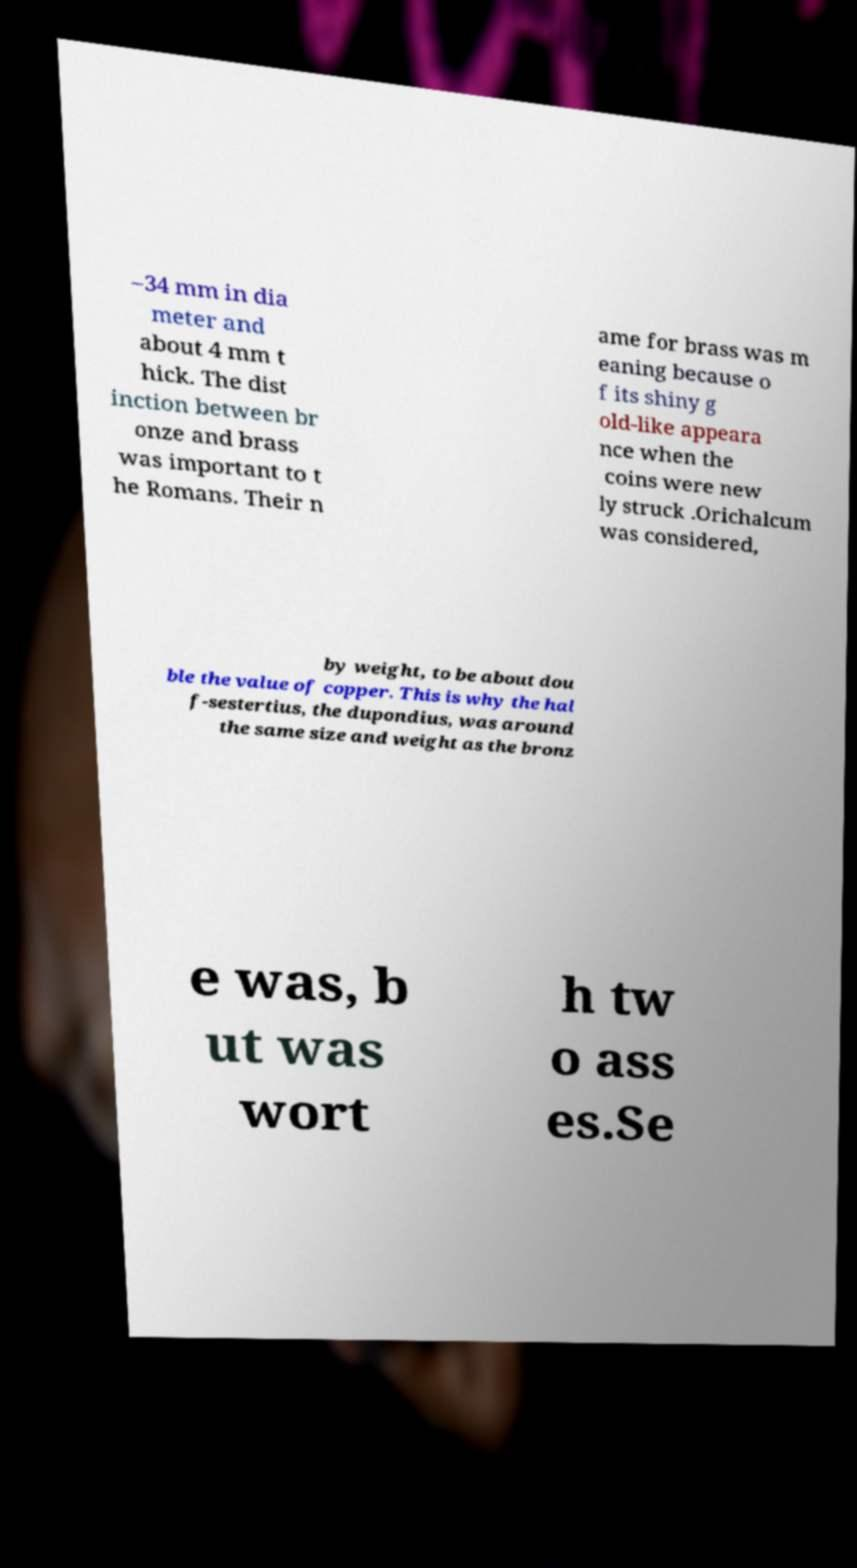Could you assist in decoding the text presented in this image and type it out clearly? –34 mm in dia meter and about 4 mm t hick. The dist inction between br onze and brass was important to t he Romans. Their n ame for brass was m eaning because o f its shiny g old-like appeara nce when the coins were new ly struck .Orichalcum was considered, by weight, to be about dou ble the value of copper. This is why the hal f-sestertius, the dupondius, was around the same size and weight as the bronz e was, b ut was wort h tw o ass es.Se 